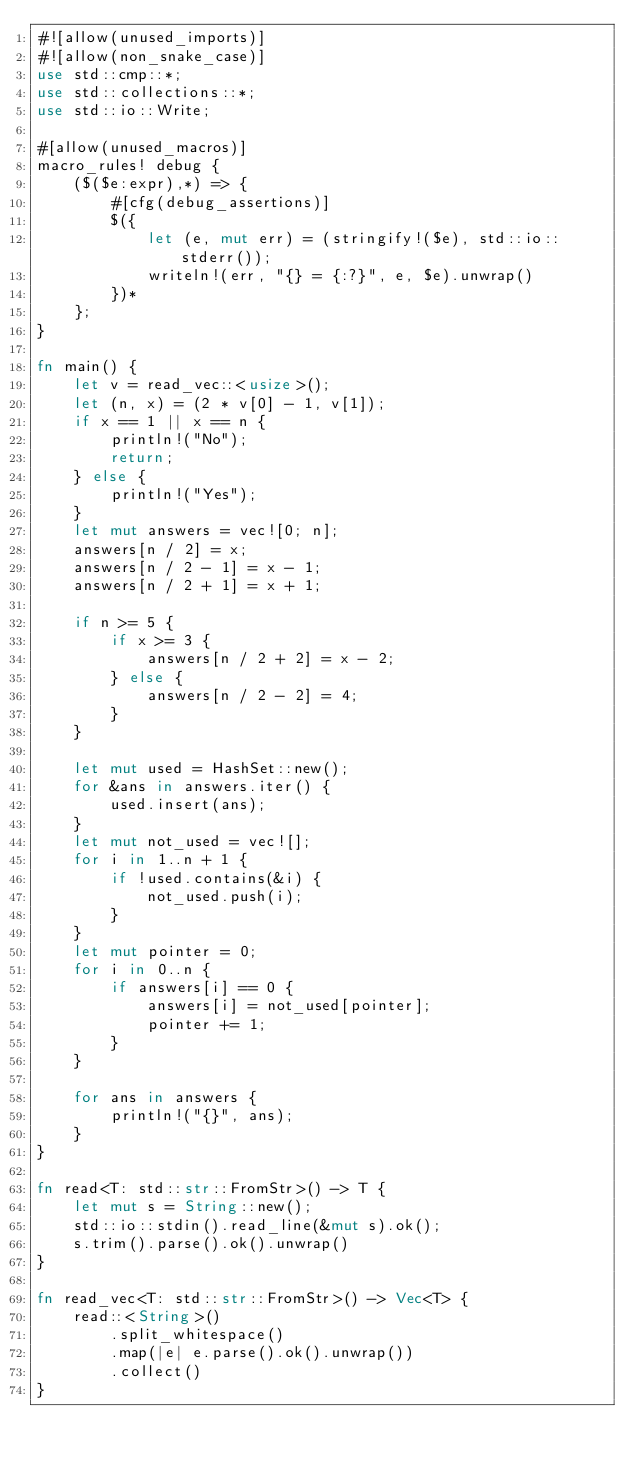Convert code to text. <code><loc_0><loc_0><loc_500><loc_500><_Rust_>#![allow(unused_imports)]
#![allow(non_snake_case)]
use std::cmp::*;
use std::collections::*;
use std::io::Write;

#[allow(unused_macros)]
macro_rules! debug {
    ($($e:expr),*) => {
        #[cfg(debug_assertions)]
        $({
            let (e, mut err) = (stringify!($e), std::io::stderr());
            writeln!(err, "{} = {:?}", e, $e).unwrap()
        })*
    };
}

fn main() {
    let v = read_vec::<usize>();
    let (n, x) = (2 * v[0] - 1, v[1]);
    if x == 1 || x == n {
        println!("No");
        return;
    } else {
        println!("Yes");
    }
    let mut answers = vec![0; n];
    answers[n / 2] = x;
    answers[n / 2 - 1] = x - 1;
    answers[n / 2 + 1] = x + 1;

    if n >= 5 {
        if x >= 3 {
            answers[n / 2 + 2] = x - 2;
        } else {
            answers[n / 2 - 2] = 4;
        }
    }

    let mut used = HashSet::new();
    for &ans in answers.iter() {
        used.insert(ans);
    }
    let mut not_used = vec![];
    for i in 1..n + 1 {
        if !used.contains(&i) {
            not_used.push(i);
        }
    }
    let mut pointer = 0;
    for i in 0..n {
        if answers[i] == 0 {
            answers[i] = not_used[pointer];
            pointer += 1;
        }
    }

    for ans in answers {
        println!("{}", ans);
    }
}

fn read<T: std::str::FromStr>() -> T {
    let mut s = String::new();
    std::io::stdin().read_line(&mut s).ok();
    s.trim().parse().ok().unwrap()
}

fn read_vec<T: std::str::FromStr>() -> Vec<T> {
    read::<String>()
        .split_whitespace()
        .map(|e| e.parse().ok().unwrap())
        .collect()
}
</code> 